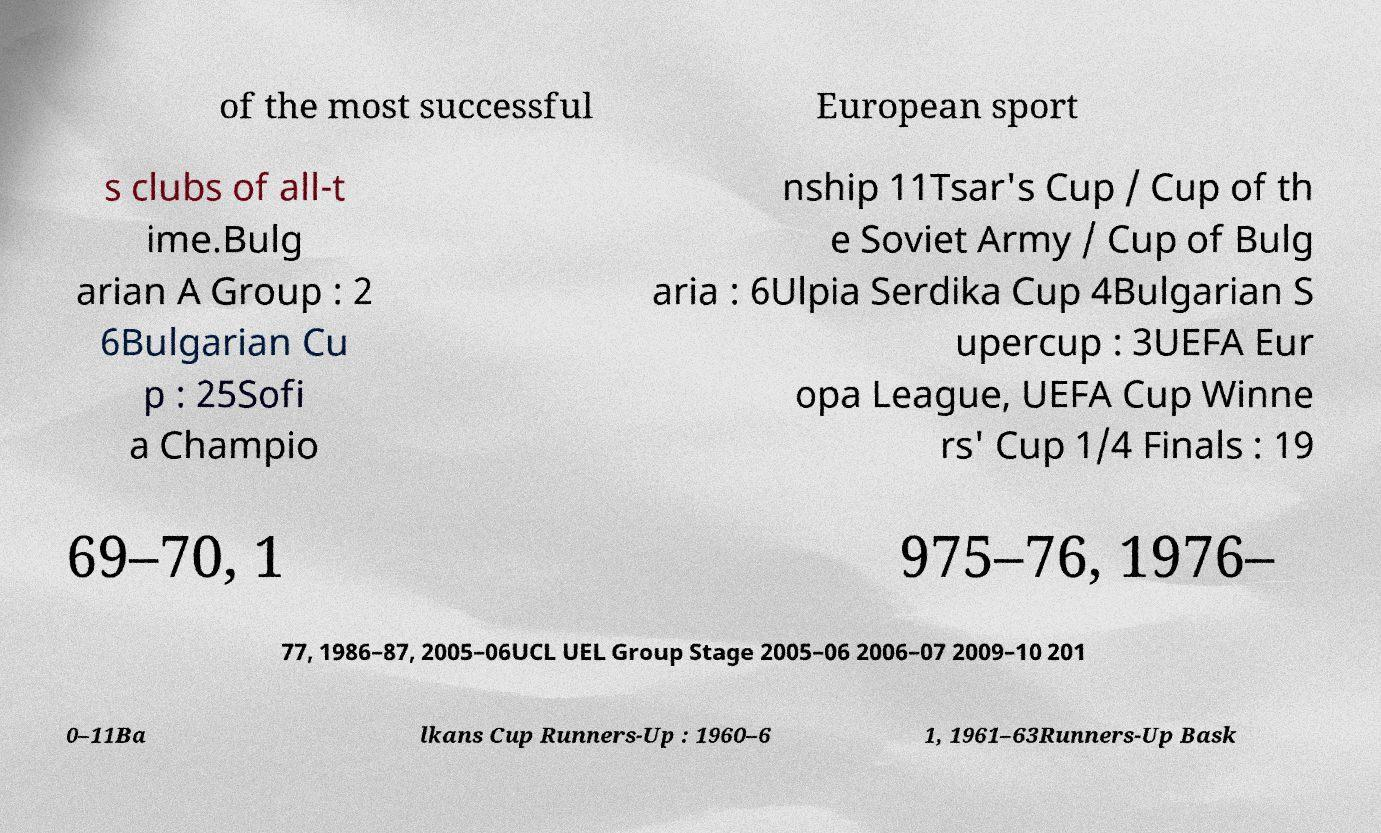I need the written content from this picture converted into text. Can you do that? of the most successful European sport s clubs of all-t ime.Bulg arian A Group : 2 6Bulgarian Cu p : 25Sofi a Champio nship 11Tsar's Cup / Cup of th e Soviet Army / Cup of Bulg aria : 6Ulpia Serdika Cup 4Bulgarian S upercup : 3UEFA Eur opa League, UEFA Cup Winne rs' Cup 1/4 Finals : 19 69–70, 1 975–76, 1976– 77, 1986–87, 2005–06UCL UEL Group Stage 2005–06 2006–07 2009–10 201 0–11Ba lkans Cup Runners-Up : 1960–6 1, 1961–63Runners-Up Bask 